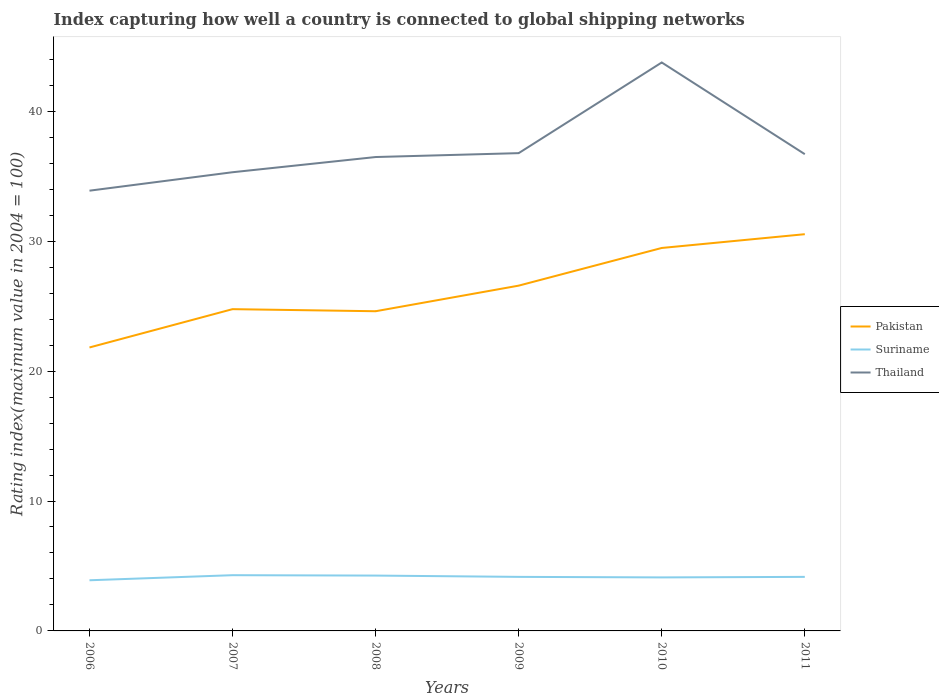Across all years, what is the maximum rating index in Thailand?
Offer a very short reply. 33.89. In which year was the rating index in Pakistan maximum?
Give a very brief answer. 2006. What is the total rating index in Suriname in the graph?
Your response must be concise. 0.1. What is the difference between the highest and the second highest rating index in Thailand?
Your response must be concise. 9.87. What is the difference between the highest and the lowest rating index in Thailand?
Your response must be concise. 1. Is the rating index in Suriname strictly greater than the rating index in Pakistan over the years?
Keep it short and to the point. Yes. Are the values on the major ticks of Y-axis written in scientific E-notation?
Offer a very short reply. No. Does the graph contain any zero values?
Your answer should be very brief. No. Where does the legend appear in the graph?
Offer a very short reply. Center right. How many legend labels are there?
Ensure brevity in your answer.  3. How are the legend labels stacked?
Ensure brevity in your answer.  Vertical. What is the title of the graph?
Provide a short and direct response. Index capturing how well a country is connected to global shipping networks. What is the label or title of the X-axis?
Your response must be concise. Years. What is the label or title of the Y-axis?
Provide a succinct answer. Rating index(maximum value in 2004 = 100). What is the Rating index(maximum value in 2004 = 100) in Pakistan in 2006?
Give a very brief answer. 21.82. What is the Rating index(maximum value in 2004 = 100) of Suriname in 2006?
Offer a very short reply. 3.9. What is the Rating index(maximum value in 2004 = 100) of Thailand in 2006?
Your response must be concise. 33.89. What is the Rating index(maximum value in 2004 = 100) in Pakistan in 2007?
Offer a very short reply. 24.77. What is the Rating index(maximum value in 2004 = 100) in Suriname in 2007?
Your answer should be very brief. 4.29. What is the Rating index(maximum value in 2004 = 100) of Thailand in 2007?
Your answer should be compact. 35.31. What is the Rating index(maximum value in 2004 = 100) in Pakistan in 2008?
Your answer should be compact. 24.61. What is the Rating index(maximum value in 2004 = 100) in Suriname in 2008?
Your response must be concise. 4.26. What is the Rating index(maximum value in 2004 = 100) in Thailand in 2008?
Offer a very short reply. 36.48. What is the Rating index(maximum value in 2004 = 100) of Pakistan in 2009?
Provide a short and direct response. 26.58. What is the Rating index(maximum value in 2004 = 100) of Suriname in 2009?
Make the answer very short. 4.16. What is the Rating index(maximum value in 2004 = 100) of Thailand in 2009?
Offer a very short reply. 36.78. What is the Rating index(maximum value in 2004 = 100) of Pakistan in 2010?
Your answer should be compact. 29.48. What is the Rating index(maximum value in 2004 = 100) in Suriname in 2010?
Give a very brief answer. 4.12. What is the Rating index(maximum value in 2004 = 100) in Thailand in 2010?
Ensure brevity in your answer.  43.76. What is the Rating index(maximum value in 2004 = 100) of Pakistan in 2011?
Keep it short and to the point. 30.54. What is the Rating index(maximum value in 2004 = 100) of Suriname in 2011?
Ensure brevity in your answer.  4.16. What is the Rating index(maximum value in 2004 = 100) in Thailand in 2011?
Your answer should be very brief. 36.7. Across all years, what is the maximum Rating index(maximum value in 2004 = 100) in Pakistan?
Provide a short and direct response. 30.54. Across all years, what is the maximum Rating index(maximum value in 2004 = 100) of Suriname?
Your answer should be very brief. 4.29. Across all years, what is the maximum Rating index(maximum value in 2004 = 100) of Thailand?
Offer a terse response. 43.76. Across all years, what is the minimum Rating index(maximum value in 2004 = 100) in Pakistan?
Your answer should be compact. 21.82. Across all years, what is the minimum Rating index(maximum value in 2004 = 100) in Suriname?
Give a very brief answer. 3.9. Across all years, what is the minimum Rating index(maximum value in 2004 = 100) of Thailand?
Your answer should be very brief. 33.89. What is the total Rating index(maximum value in 2004 = 100) in Pakistan in the graph?
Provide a succinct answer. 157.8. What is the total Rating index(maximum value in 2004 = 100) of Suriname in the graph?
Offer a terse response. 24.89. What is the total Rating index(maximum value in 2004 = 100) in Thailand in the graph?
Your answer should be very brief. 222.92. What is the difference between the Rating index(maximum value in 2004 = 100) of Pakistan in 2006 and that in 2007?
Your response must be concise. -2.95. What is the difference between the Rating index(maximum value in 2004 = 100) in Suriname in 2006 and that in 2007?
Your answer should be very brief. -0.39. What is the difference between the Rating index(maximum value in 2004 = 100) in Thailand in 2006 and that in 2007?
Offer a very short reply. -1.42. What is the difference between the Rating index(maximum value in 2004 = 100) of Pakistan in 2006 and that in 2008?
Provide a succinct answer. -2.79. What is the difference between the Rating index(maximum value in 2004 = 100) in Suriname in 2006 and that in 2008?
Your answer should be compact. -0.36. What is the difference between the Rating index(maximum value in 2004 = 100) of Thailand in 2006 and that in 2008?
Provide a short and direct response. -2.59. What is the difference between the Rating index(maximum value in 2004 = 100) in Pakistan in 2006 and that in 2009?
Offer a very short reply. -4.76. What is the difference between the Rating index(maximum value in 2004 = 100) of Suriname in 2006 and that in 2009?
Keep it short and to the point. -0.26. What is the difference between the Rating index(maximum value in 2004 = 100) in Thailand in 2006 and that in 2009?
Your answer should be compact. -2.89. What is the difference between the Rating index(maximum value in 2004 = 100) of Pakistan in 2006 and that in 2010?
Provide a short and direct response. -7.66. What is the difference between the Rating index(maximum value in 2004 = 100) of Suriname in 2006 and that in 2010?
Your answer should be very brief. -0.22. What is the difference between the Rating index(maximum value in 2004 = 100) in Thailand in 2006 and that in 2010?
Offer a very short reply. -9.87. What is the difference between the Rating index(maximum value in 2004 = 100) in Pakistan in 2006 and that in 2011?
Keep it short and to the point. -8.72. What is the difference between the Rating index(maximum value in 2004 = 100) of Suriname in 2006 and that in 2011?
Keep it short and to the point. -0.26. What is the difference between the Rating index(maximum value in 2004 = 100) in Thailand in 2006 and that in 2011?
Offer a very short reply. -2.81. What is the difference between the Rating index(maximum value in 2004 = 100) of Pakistan in 2007 and that in 2008?
Your answer should be very brief. 0.16. What is the difference between the Rating index(maximum value in 2004 = 100) of Thailand in 2007 and that in 2008?
Your response must be concise. -1.17. What is the difference between the Rating index(maximum value in 2004 = 100) of Pakistan in 2007 and that in 2009?
Provide a succinct answer. -1.81. What is the difference between the Rating index(maximum value in 2004 = 100) in Suriname in 2007 and that in 2009?
Keep it short and to the point. 0.13. What is the difference between the Rating index(maximum value in 2004 = 100) of Thailand in 2007 and that in 2009?
Make the answer very short. -1.47. What is the difference between the Rating index(maximum value in 2004 = 100) in Pakistan in 2007 and that in 2010?
Give a very brief answer. -4.71. What is the difference between the Rating index(maximum value in 2004 = 100) of Suriname in 2007 and that in 2010?
Your answer should be compact. 0.17. What is the difference between the Rating index(maximum value in 2004 = 100) of Thailand in 2007 and that in 2010?
Keep it short and to the point. -8.45. What is the difference between the Rating index(maximum value in 2004 = 100) in Pakistan in 2007 and that in 2011?
Offer a terse response. -5.77. What is the difference between the Rating index(maximum value in 2004 = 100) in Suriname in 2007 and that in 2011?
Offer a very short reply. 0.13. What is the difference between the Rating index(maximum value in 2004 = 100) in Thailand in 2007 and that in 2011?
Ensure brevity in your answer.  -1.39. What is the difference between the Rating index(maximum value in 2004 = 100) in Pakistan in 2008 and that in 2009?
Your answer should be compact. -1.97. What is the difference between the Rating index(maximum value in 2004 = 100) in Suriname in 2008 and that in 2009?
Provide a short and direct response. 0.1. What is the difference between the Rating index(maximum value in 2004 = 100) in Thailand in 2008 and that in 2009?
Keep it short and to the point. -0.3. What is the difference between the Rating index(maximum value in 2004 = 100) of Pakistan in 2008 and that in 2010?
Give a very brief answer. -4.87. What is the difference between the Rating index(maximum value in 2004 = 100) in Suriname in 2008 and that in 2010?
Provide a short and direct response. 0.14. What is the difference between the Rating index(maximum value in 2004 = 100) of Thailand in 2008 and that in 2010?
Your response must be concise. -7.28. What is the difference between the Rating index(maximum value in 2004 = 100) of Pakistan in 2008 and that in 2011?
Keep it short and to the point. -5.93. What is the difference between the Rating index(maximum value in 2004 = 100) in Thailand in 2008 and that in 2011?
Provide a succinct answer. -0.22. What is the difference between the Rating index(maximum value in 2004 = 100) of Suriname in 2009 and that in 2010?
Ensure brevity in your answer.  0.04. What is the difference between the Rating index(maximum value in 2004 = 100) in Thailand in 2009 and that in 2010?
Make the answer very short. -6.98. What is the difference between the Rating index(maximum value in 2004 = 100) of Pakistan in 2009 and that in 2011?
Offer a very short reply. -3.96. What is the difference between the Rating index(maximum value in 2004 = 100) of Suriname in 2009 and that in 2011?
Ensure brevity in your answer.  0. What is the difference between the Rating index(maximum value in 2004 = 100) of Thailand in 2009 and that in 2011?
Give a very brief answer. 0.08. What is the difference between the Rating index(maximum value in 2004 = 100) of Pakistan in 2010 and that in 2011?
Keep it short and to the point. -1.06. What is the difference between the Rating index(maximum value in 2004 = 100) in Suriname in 2010 and that in 2011?
Ensure brevity in your answer.  -0.04. What is the difference between the Rating index(maximum value in 2004 = 100) in Thailand in 2010 and that in 2011?
Your answer should be very brief. 7.06. What is the difference between the Rating index(maximum value in 2004 = 100) in Pakistan in 2006 and the Rating index(maximum value in 2004 = 100) in Suriname in 2007?
Your answer should be compact. 17.53. What is the difference between the Rating index(maximum value in 2004 = 100) of Pakistan in 2006 and the Rating index(maximum value in 2004 = 100) of Thailand in 2007?
Give a very brief answer. -13.49. What is the difference between the Rating index(maximum value in 2004 = 100) in Suriname in 2006 and the Rating index(maximum value in 2004 = 100) in Thailand in 2007?
Keep it short and to the point. -31.41. What is the difference between the Rating index(maximum value in 2004 = 100) of Pakistan in 2006 and the Rating index(maximum value in 2004 = 100) of Suriname in 2008?
Offer a terse response. 17.56. What is the difference between the Rating index(maximum value in 2004 = 100) in Pakistan in 2006 and the Rating index(maximum value in 2004 = 100) in Thailand in 2008?
Make the answer very short. -14.66. What is the difference between the Rating index(maximum value in 2004 = 100) of Suriname in 2006 and the Rating index(maximum value in 2004 = 100) of Thailand in 2008?
Offer a very short reply. -32.58. What is the difference between the Rating index(maximum value in 2004 = 100) of Pakistan in 2006 and the Rating index(maximum value in 2004 = 100) of Suriname in 2009?
Offer a terse response. 17.66. What is the difference between the Rating index(maximum value in 2004 = 100) in Pakistan in 2006 and the Rating index(maximum value in 2004 = 100) in Thailand in 2009?
Give a very brief answer. -14.96. What is the difference between the Rating index(maximum value in 2004 = 100) of Suriname in 2006 and the Rating index(maximum value in 2004 = 100) of Thailand in 2009?
Offer a very short reply. -32.88. What is the difference between the Rating index(maximum value in 2004 = 100) of Pakistan in 2006 and the Rating index(maximum value in 2004 = 100) of Thailand in 2010?
Provide a succinct answer. -21.94. What is the difference between the Rating index(maximum value in 2004 = 100) in Suriname in 2006 and the Rating index(maximum value in 2004 = 100) in Thailand in 2010?
Make the answer very short. -39.86. What is the difference between the Rating index(maximum value in 2004 = 100) of Pakistan in 2006 and the Rating index(maximum value in 2004 = 100) of Suriname in 2011?
Ensure brevity in your answer.  17.66. What is the difference between the Rating index(maximum value in 2004 = 100) of Pakistan in 2006 and the Rating index(maximum value in 2004 = 100) of Thailand in 2011?
Ensure brevity in your answer.  -14.88. What is the difference between the Rating index(maximum value in 2004 = 100) of Suriname in 2006 and the Rating index(maximum value in 2004 = 100) of Thailand in 2011?
Your answer should be compact. -32.8. What is the difference between the Rating index(maximum value in 2004 = 100) of Pakistan in 2007 and the Rating index(maximum value in 2004 = 100) of Suriname in 2008?
Provide a short and direct response. 20.51. What is the difference between the Rating index(maximum value in 2004 = 100) of Pakistan in 2007 and the Rating index(maximum value in 2004 = 100) of Thailand in 2008?
Your response must be concise. -11.71. What is the difference between the Rating index(maximum value in 2004 = 100) in Suriname in 2007 and the Rating index(maximum value in 2004 = 100) in Thailand in 2008?
Give a very brief answer. -32.19. What is the difference between the Rating index(maximum value in 2004 = 100) of Pakistan in 2007 and the Rating index(maximum value in 2004 = 100) of Suriname in 2009?
Give a very brief answer. 20.61. What is the difference between the Rating index(maximum value in 2004 = 100) in Pakistan in 2007 and the Rating index(maximum value in 2004 = 100) in Thailand in 2009?
Provide a succinct answer. -12.01. What is the difference between the Rating index(maximum value in 2004 = 100) in Suriname in 2007 and the Rating index(maximum value in 2004 = 100) in Thailand in 2009?
Provide a succinct answer. -32.49. What is the difference between the Rating index(maximum value in 2004 = 100) of Pakistan in 2007 and the Rating index(maximum value in 2004 = 100) of Suriname in 2010?
Provide a short and direct response. 20.65. What is the difference between the Rating index(maximum value in 2004 = 100) in Pakistan in 2007 and the Rating index(maximum value in 2004 = 100) in Thailand in 2010?
Provide a succinct answer. -18.99. What is the difference between the Rating index(maximum value in 2004 = 100) in Suriname in 2007 and the Rating index(maximum value in 2004 = 100) in Thailand in 2010?
Your answer should be compact. -39.47. What is the difference between the Rating index(maximum value in 2004 = 100) of Pakistan in 2007 and the Rating index(maximum value in 2004 = 100) of Suriname in 2011?
Offer a terse response. 20.61. What is the difference between the Rating index(maximum value in 2004 = 100) of Pakistan in 2007 and the Rating index(maximum value in 2004 = 100) of Thailand in 2011?
Your answer should be very brief. -11.93. What is the difference between the Rating index(maximum value in 2004 = 100) in Suriname in 2007 and the Rating index(maximum value in 2004 = 100) in Thailand in 2011?
Keep it short and to the point. -32.41. What is the difference between the Rating index(maximum value in 2004 = 100) in Pakistan in 2008 and the Rating index(maximum value in 2004 = 100) in Suriname in 2009?
Keep it short and to the point. 20.45. What is the difference between the Rating index(maximum value in 2004 = 100) of Pakistan in 2008 and the Rating index(maximum value in 2004 = 100) of Thailand in 2009?
Make the answer very short. -12.17. What is the difference between the Rating index(maximum value in 2004 = 100) in Suriname in 2008 and the Rating index(maximum value in 2004 = 100) in Thailand in 2009?
Provide a short and direct response. -32.52. What is the difference between the Rating index(maximum value in 2004 = 100) in Pakistan in 2008 and the Rating index(maximum value in 2004 = 100) in Suriname in 2010?
Provide a short and direct response. 20.49. What is the difference between the Rating index(maximum value in 2004 = 100) of Pakistan in 2008 and the Rating index(maximum value in 2004 = 100) of Thailand in 2010?
Keep it short and to the point. -19.15. What is the difference between the Rating index(maximum value in 2004 = 100) of Suriname in 2008 and the Rating index(maximum value in 2004 = 100) of Thailand in 2010?
Ensure brevity in your answer.  -39.5. What is the difference between the Rating index(maximum value in 2004 = 100) of Pakistan in 2008 and the Rating index(maximum value in 2004 = 100) of Suriname in 2011?
Offer a very short reply. 20.45. What is the difference between the Rating index(maximum value in 2004 = 100) of Pakistan in 2008 and the Rating index(maximum value in 2004 = 100) of Thailand in 2011?
Keep it short and to the point. -12.09. What is the difference between the Rating index(maximum value in 2004 = 100) of Suriname in 2008 and the Rating index(maximum value in 2004 = 100) of Thailand in 2011?
Make the answer very short. -32.44. What is the difference between the Rating index(maximum value in 2004 = 100) in Pakistan in 2009 and the Rating index(maximum value in 2004 = 100) in Suriname in 2010?
Keep it short and to the point. 22.46. What is the difference between the Rating index(maximum value in 2004 = 100) of Pakistan in 2009 and the Rating index(maximum value in 2004 = 100) of Thailand in 2010?
Give a very brief answer. -17.18. What is the difference between the Rating index(maximum value in 2004 = 100) in Suriname in 2009 and the Rating index(maximum value in 2004 = 100) in Thailand in 2010?
Give a very brief answer. -39.6. What is the difference between the Rating index(maximum value in 2004 = 100) in Pakistan in 2009 and the Rating index(maximum value in 2004 = 100) in Suriname in 2011?
Your answer should be very brief. 22.42. What is the difference between the Rating index(maximum value in 2004 = 100) of Pakistan in 2009 and the Rating index(maximum value in 2004 = 100) of Thailand in 2011?
Your answer should be very brief. -10.12. What is the difference between the Rating index(maximum value in 2004 = 100) in Suriname in 2009 and the Rating index(maximum value in 2004 = 100) in Thailand in 2011?
Offer a terse response. -32.54. What is the difference between the Rating index(maximum value in 2004 = 100) in Pakistan in 2010 and the Rating index(maximum value in 2004 = 100) in Suriname in 2011?
Provide a succinct answer. 25.32. What is the difference between the Rating index(maximum value in 2004 = 100) in Pakistan in 2010 and the Rating index(maximum value in 2004 = 100) in Thailand in 2011?
Ensure brevity in your answer.  -7.22. What is the difference between the Rating index(maximum value in 2004 = 100) in Suriname in 2010 and the Rating index(maximum value in 2004 = 100) in Thailand in 2011?
Your response must be concise. -32.58. What is the average Rating index(maximum value in 2004 = 100) of Pakistan per year?
Ensure brevity in your answer.  26.3. What is the average Rating index(maximum value in 2004 = 100) of Suriname per year?
Provide a short and direct response. 4.15. What is the average Rating index(maximum value in 2004 = 100) in Thailand per year?
Keep it short and to the point. 37.15. In the year 2006, what is the difference between the Rating index(maximum value in 2004 = 100) in Pakistan and Rating index(maximum value in 2004 = 100) in Suriname?
Provide a short and direct response. 17.92. In the year 2006, what is the difference between the Rating index(maximum value in 2004 = 100) of Pakistan and Rating index(maximum value in 2004 = 100) of Thailand?
Give a very brief answer. -12.07. In the year 2006, what is the difference between the Rating index(maximum value in 2004 = 100) of Suriname and Rating index(maximum value in 2004 = 100) of Thailand?
Offer a very short reply. -29.99. In the year 2007, what is the difference between the Rating index(maximum value in 2004 = 100) in Pakistan and Rating index(maximum value in 2004 = 100) in Suriname?
Keep it short and to the point. 20.48. In the year 2007, what is the difference between the Rating index(maximum value in 2004 = 100) of Pakistan and Rating index(maximum value in 2004 = 100) of Thailand?
Your response must be concise. -10.54. In the year 2007, what is the difference between the Rating index(maximum value in 2004 = 100) of Suriname and Rating index(maximum value in 2004 = 100) of Thailand?
Your answer should be very brief. -31.02. In the year 2008, what is the difference between the Rating index(maximum value in 2004 = 100) of Pakistan and Rating index(maximum value in 2004 = 100) of Suriname?
Provide a short and direct response. 20.35. In the year 2008, what is the difference between the Rating index(maximum value in 2004 = 100) of Pakistan and Rating index(maximum value in 2004 = 100) of Thailand?
Offer a very short reply. -11.87. In the year 2008, what is the difference between the Rating index(maximum value in 2004 = 100) in Suriname and Rating index(maximum value in 2004 = 100) in Thailand?
Provide a short and direct response. -32.22. In the year 2009, what is the difference between the Rating index(maximum value in 2004 = 100) of Pakistan and Rating index(maximum value in 2004 = 100) of Suriname?
Provide a succinct answer. 22.42. In the year 2009, what is the difference between the Rating index(maximum value in 2004 = 100) of Suriname and Rating index(maximum value in 2004 = 100) of Thailand?
Keep it short and to the point. -32.62. In the year 2010, what is the difference between the Rating index(maximum value in 2004 = 100) of Pakistan and Rating index(maximum value in 2004 = 100) of Suriname?
Your answer should be very brief. 25.36. In the year 2010, what is the difference between the Rating index(maximum value in 2004 = 100) of Pakistan and Rating index(maximum value in 2004 = 100) of Thailand?
Make the answer very short. -14.28. In the year 2010, what is the difference between the Rating index(maximum value in 2004 = 100) in Suriname and Rating index(maximum value in 2004 = 100) in Thailand?
Provide a short and direct response. -39.64. In the year 2011, what is the difference between the Rating index(maximum value in 2004 = 100) in Pakistan and Rating index(maximum value in 2004 = 100) in Suriname?
Give a very brief answer. 26.38. In the year 2011, what is the difference between the Rating index(maximum value in 2004 = 100) in Pakistan and Rating index(maximum value in 2004 = 100) in Thailand?
Give a very brief answer. -6.16. In the year 2011, what is the difference between the Rating index(maximum value in 2004 = 100) of Suriname and Rating index(maximum value in 2004 = 100) of Thailand?
Make the answer very short. -32.54. What is the ratio of the Rating index(maximum value in 2004 = 100) of Pakistan in 2006 to that in 2007?
Your answer should be very brief. 0.88. What is the ratio of the Rating index(maximum value in 2004 = 100) of Suriname in 2006 to that in 2007?
Make the answer very short. 0.91. What is the ratio of the Rating index(maximum value in 2004 = 100) in Thailand in 2006 to that in 2007?
Your answer should be compact. 0.96. What is the ratio of the Rating index(maximum value in 2004 = 100) in Pakistan in 2006 to that in 2008?
Offer a very short reply. 0.89. What is the ratio of the Rating index(maximum value in 2004 = 100) in Suriname in 2006 to that in 2008?
Offer a very short reply. 0.92. What is the ratio of the Rating index(maximum value in 2004 = 100) in Thailand in 2006 to that in 2008?
Offer a very short reply. 0.93. What is the ratio of the Rating index(maximum value in 2004 = 100) of Pakistan in 2006 to that in 2009?
Your answer should be very brief. 0.82. What is the ratio of the Rating index(maximum value in 2004 = 100) of Thailand in 2006 to that in 2009?
Offer a very short reply. 0.92. What is the ratio of the Rating index(maximum value in 2004 = 100) of Pakistan in 2006 to that in 2010?
Make the answer very short. 0.74. What is the ratio of the Rating index(maximum value in 2004 = 100) of Suriname in 2006 to that in 2010?
Your answer should be very brief. 0.95. What is the ratio of the Rating index(maximum value in 2004 = 100) of Thailand in 2006 to that in 2010?
Provide a short and direct response. 0.77. What is the ratio of the Rating index(maximum value in 2004 = 100) in Pakistan in 2006 to that in 2011?
Offer a very short reply. 0.71. What is the ratio of the Rating index(maximum value in 2004 = 100) of Suriname in 2006 to that in 2011?
Your answer should be very brief. 0.94. What is the ratio of the Rating index(maximum value in 2004 = 100) in Thailand in 2006 to that in 2011?
Provide a succinct answer. 0.92. What is the ratio of the Rating index(maximum value in 2004 = 100) in Pakistan in 2007 to that in 2008?
Give a very brief answer. 1.01. What is the ratio of the Rating index(maximum value in 2004 = 100) in Thailand in 2007 to that in 2008?
Ensure brevity in your answer.  0.97. What is the ratio of the Rating index(maximum value in 2004 = 100) of Pakistan in 2007 to that in 2009?
Offer a very short reply. 0.93. What is the ratio of the Rating index(maximum value in 2004 = 100) of Suriname in 2007 to that in 2009?
Give a very brief answer. 1.03. What is the ratio of the Rating index(maximum value in 2004 = 100) of Thailand in 2007 to that in 2009?
Offer a terse response. 0.96. What is the ratio of the Rating index(maximum value in 2004 = 100) of Pakistan in 2007 to that in 2010?
Offer a very short reply. 0.84. What is the ratio of the Rating index(maximum value in 2004 = 100) in Suriname in 2007 to that in 2010?
Provide a short and direct response. 1.04. What is the ratio of the Rating index(maximum value in 2004 = 100) of Thailand in 2007 to that in 2010?
Make the answer very short. 0.81. What is the ratio of the Rating index(maximum value in 2004 = 100) in Pakistan in 2007 to that in 2011?
Provide a succinct answer. 0.81. What is the ratio of the Rating index(maximum value in 2004 = 100) in Suriname in 2007 to that in 2011?
Make the answer very short. 1.03. What is the ratio of the Rating index(maximum value in 2004 = 100) of Thailand in 2007 to that in 2011?
Offer a terse response. 0.96. What is the ratio of the Rating index(maximum value in 2004 = 100) in Pakistan in 2008 to that in 2009?
Make the answer very short. 0.93. What is the ratio of the Rating index(maximum value in 2004 = 100) of Suriname in 2008 to that in 2009?
Make the answer very short. 1.02. What is the ratio of the Rating index(maximum value in 2004 = 100) in Pakistan in 2008 to that in 2010?
Keep it short and to the point. 0.83. What is the ratio of the Rating index(maximum value in 2004 = 100) in Suriname in 2008 to that in 2010?
Offer a very short reply. 1.03. What is the ratio of the Rating index(maximum value in 2004 = 100) of Thailand in 2008 to that in 2010?
Ensure brevity in your answer.  0.83. What is the ratio of the Rating index(maximum value in 2004 = 100) of Pakistan in 2008 to that in 2011?
Ensure brevity in your answer.  0.81. What is the ratio of the Rating index(maximum value in 2004 = 100) of Thailand in 2008 to that in 2011?
Provide a succinct answer. 0.99. What is the ratio of the Rating index(maximum value in 2004 = 100) in Pakistan in 2009 to that in 2010?
Your response must be concise. 0.9. What is the ratio of the Rating index(maximum value in 2004 = 100) in Suriname in 2009 to that in 2010?
Your response must be concise. 1.01. What is the ratio of the Rating index(maximum value in 2004 = 100) of Thailand in 2009 to that in 2010?
Offer a very short reply. 0.84. What is the ratio of the Rating index(maximum value in 2004 = 100) of Pakistan in 2009 to that in 2011?
Provide a short and direct response. 0.87. What is the ratio of the Rating index(maximum value in 2004 = 100) in Pakistan in 2010 to that in 2011?
Keep it short and to the point. 0.97. What is the ratio of the Rating index(maximum value in 2004 = 100) in Suriname in 2010 to that in 2011?
Provide a short and direct response. 0.99. What is the ratio of the Rating index(maximum value in 2004 = 100) in Thailand in 2010 to that in 2011?
Your answer should be very brief. 1.19. What is the difference between the highest and the second highest Rating index(maximum value in 2004 = 100) in Pakistan?
Your answer should be compact. 1.06. What is the difference between the highest and the second highest Rating index(maximum value in 2004 = 100) of Thailand?
Ensure brevity in your answer.  6.98. What is the difference between the highest and the lowest Rating index(maximum value in 2004 = 100) in Pakistan?
Keep it short and to the point. 8.72. What is the difference between the highest and the lowest Rating index(maximum value in 2004 = 100) in Suriname?
Offer a terse response. 0.39. What is the difference between the highest and the lowest Rating index(maximum value in 2004 = 100) in Thailand?
Ensure brevity in your answer.  9.87. 